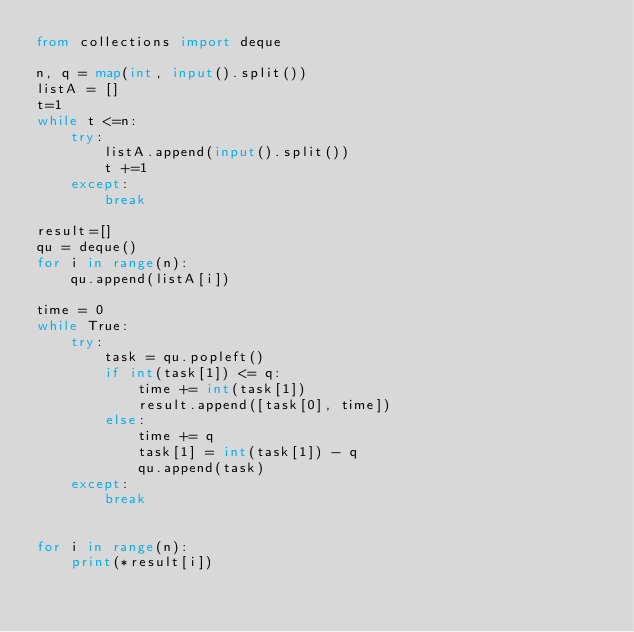Convert code to text. <code><loc_0><loc_0><loc_500><loc_500><_Python_>from collections import deque

n, q = map(int, input().split())
listA = []
t=1
while t <=n:
    try:
        listA.append(input().split())
        t +=1
    except:
        break

result=[]
qu = deque()
for i in range(n):
    qu.append(listA[i])

time = 0
while True:
    try:
        task = qu.popleft()
        if int(task[1]) <= q:
            time += int(task[1])
            result.append([task[0], time])
        else:
            time += q
            task[1] = int(task[1]) - q
            qu.append(task)
    except:
        break


for i in range(n):
    print(*result[i])
    

</code> 